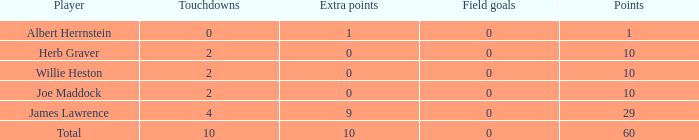What is the highest number of points for players with less than 2 touchdowns and 0 extra points? None. 